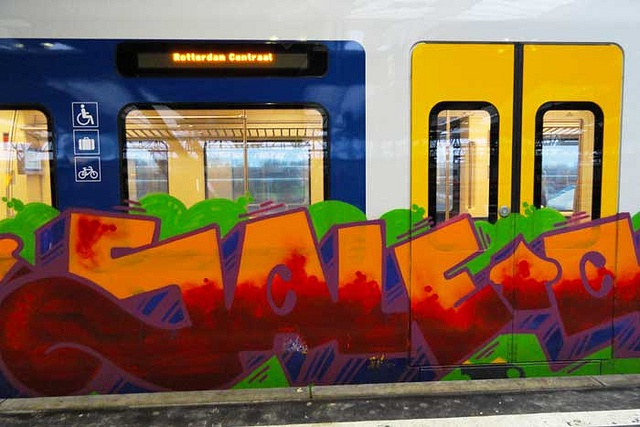Describe the objects in this image and their specific colors. I can see train in darkgray, maroon, black, red, and navy tones and bicycle in darkgray, black, and lavender tones in this image. 